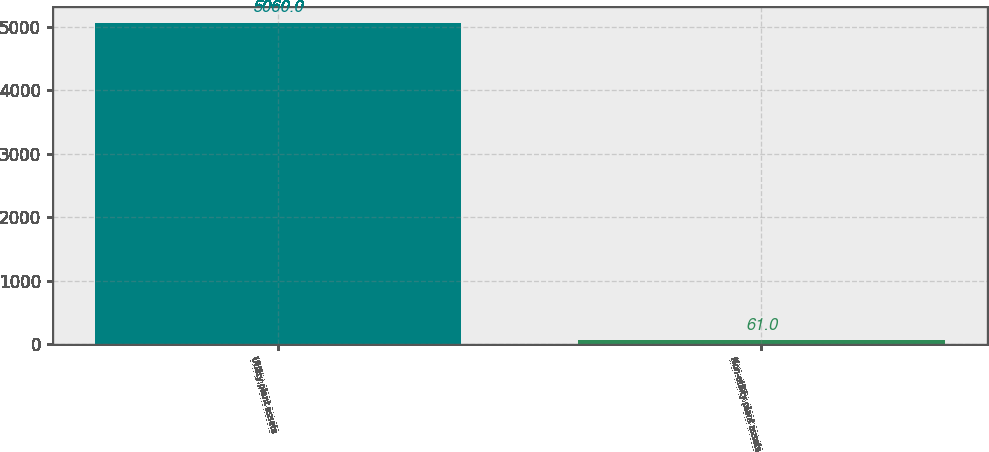Convert chart. <chart><loc_0><loc_0><loc_500><loc_500><bar_chart><fcel>Utility plant assets<fcel>Non-utility plant assets<nl><fcel>5060<fcel>61<nl></chart> 